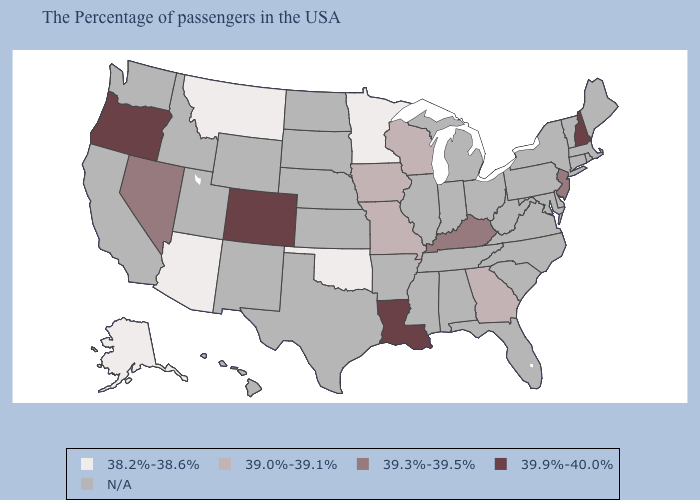Name the states that have a value in the range 39.3%-39.5%?
Quick response, please. New Jersey, Kentucky, Nevada. Among the states that border South Carolina , which have the lowest value?
Be succinct. Georgia. Among the states that border Delaware , which have the highest value?
Write a very short answer. New Jersey. What is the lowest value in the South?
Answer briefly. 38.2%-38.6%. Name the states that have a value in the range 39.0%-39.1%?
Write a very short answer. Georgia, Wisconsin, Missouri, Iowa. Name the states that have a value in the range 38.2%-38.6%?
Write a very short answer. Minnesota, Oklahoma, Montana, Arizona, Alaska. Name the states that have a value in the range N/A?
Quick response, please. Maine, Massachusetts, Rhode Island, Vermont, Connecticut, New York, Delaware, Maryland, Pennsylvania, Virginia, North Carolina, South Carolina, West Virginia, Ohio, Florida, Michigan, Indiana, Alabama, Tennessee, Illinois, Mississippi, Arkansas, Kansas, Nebraska, Texas, South Dakota, North Dakota, Wyoming, New Mexico, Utah, Idaho, California, Washington, Hawaii. Does New Jersey have the highest value in the Northeast?
Quick response, please. No. Which states have the lowest value in the USA?
Concise answer only. Minnesota, Oklahoma, Montana, Arizona, Alaska. What is the highest value in the West ?
Keep it brief. 39.9%-40.0%. Name the states that have a value in the range 39.9%-40.0%?
Concise answer only. New Hampshire, Louisiana, Colorado, Oregon. Among the states that border Tennessee , which have the highest value?
Concise answer only. Kentucky. Does the map have missing data?
Short answer required. Yes. 